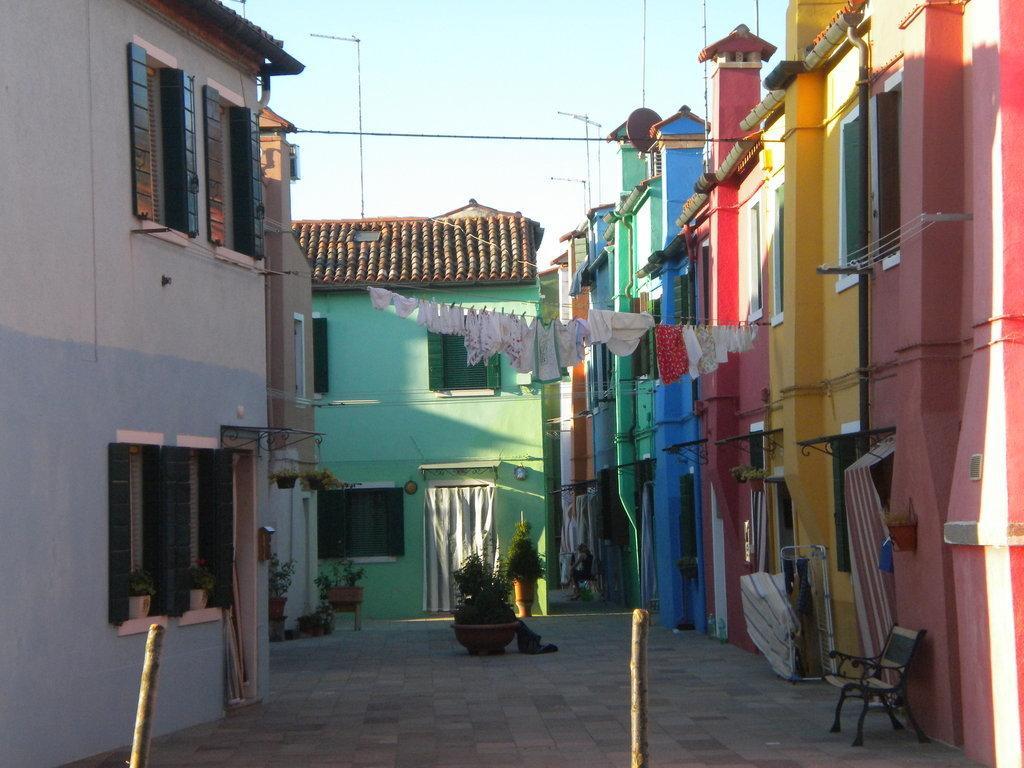Can you describe this image briefly? In this image I can see few buildings in multi color, clothes in white and red color, plants in green color, a bench. Background I can see few poles and the sky is in white color. 